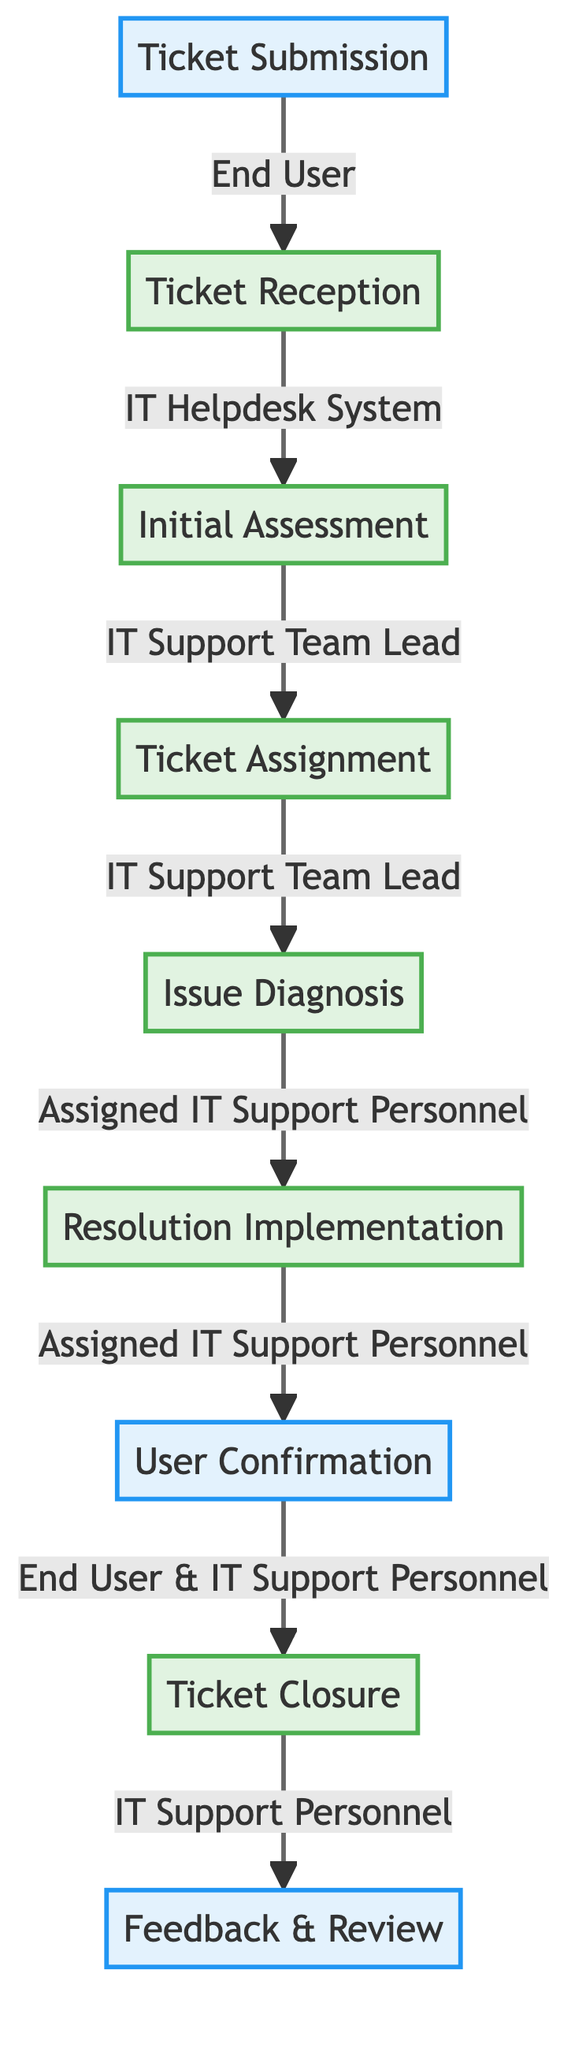What is the first step in the IT support workflow? The first step is identified as "Ticket Submission" in the diagram, where the end user submits a support request.
Answer: Ticket Submission Who is responsible for the Ticket Reception? The diagram specifies that the "IT Helpdesk System" is responsible for the Ticket Reception.
Answer: IT Helpdesk System How many total steps are involved in the IT support workflow? By counting the steps in the flowchart, there are a total of eight steps from Ticket Submission to Feedback & Review.
Answer: Eight What happens after the Initial Assessment? According to the flowchart, after the "Initial Assessment," the next step is "Ticket Assignment," handled by the IT Support Team Lead.
Answer: Ticket Assignment Which two entities are involved in the User Confirmation step? The diagram indicates that "End User" and "IT Support Personnel" both play roles in the User Confirmation step.
Answer: End User & IT Support Personnel What action is taken during the Resolution Implementation? The "Assigned IT Support Personnel" performs several actions during the Resolution Implementation, including implementing the solution and verifying issue resolution.
Answer: Implement solution Which step comes before Feedback & Review in the workflow? The flowchart shows that "Ticket Closure" comes immediately before the "Feedback & Review" step in the IT support workflow.
Answer: Ticket Closure What is the primary action taken in Ticket Closure? In the Ticket Closure step, the primary action is to close the ticket in the system, as indicated in the diagram.
Answer: Close ticket in system What is the role of IT Support Team Lead during Ticket Assignment? The role of the IT Support Team Lead during Ticket Assignment is to select support personnel or team and delegate the ticket.
Answer: Select support personnel or team 